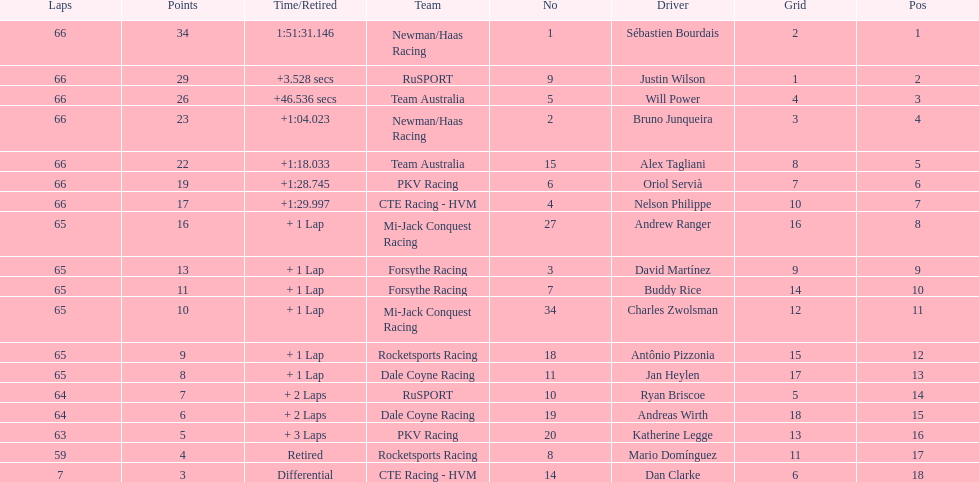At the 2006 gran premio telmex, did oriol servia or katherine legge complete more laps? Oriol Servià. Could you parse the entire table? {'header': ['Laps', 'Points', 'Time/Retired', 'Team', 'No', 'Driver', 'Grid', 'Pos'], 'rows': [['66', '34', '1:51:31.146', 'Newman/Haas Racing', '1', 'Sébastien Bourdais', '2', '1'], ['66', '29', '+3.528 secs', 'RuSPORT', '9', 'Justin Wilson', '1', '2'], ['66', '26', '+46.536 secs', 'Team Australia', '5', 'Will Power', '4', '3'], ['66', '23', '+1:04.023', 'Newman/Haas Racing', '2', 'Bruno Junqueira', '3', '4'], ['66', '22', '+1:18.033', 'Team Australia', '15', 'Alex Tagliani', '8', '5'], ['66', '19', '+1:28.745', 'PKV Racing', '6', 'Oriol Servià', '7', '6'], ['66', '17', '+1:29.997', 'CTE Racing - HVM', '4', 'Nelson Philippe', '10', '7'], ['65', '16', '+ 1 Lap', 'Mi-Jack Conquest Racing', '27', 'Andrew Ranger', '16', '8'], ['65', '13', '+ 1 Lap', 'Forsythe Racing', '3', 'David Martínez', '9', '9'], ['65', '11', '+ 1 Lap', 'Forsythe Racing', '7', 'Buddy Rice', '14', '10'], ['65', '10', '+ 1 Lap', 'Mi-Jack Conquest Racing', '34', 'Charles Zwolsman', '12', '11'], ['65', '9', '+ 1 Lap', 'Rocketsports Racing', '18', 'Antônio Pizzonia', '15', '12'], ['65', '8', '+ 1 Lap', 'Dale Coyne Racing', '11', 'Jan Heylen', '17', '13'], ['64', '7', '+ 2 Laps', 'RuSPORT', '10', 'Ryan Briscoe', '5', '14'], ['64', '6', '+ 2 Laps', 'Dale Coyne Racing', '19', 'Andreas Wirth', '18', '15'], ['63', '5', '+ 3 Laps', 'PKV Racing', '20', 'Katherine Legge', '13', '16'], ['59', '4', 'Retired', 'Rocketsports Racing', '8', 'Mario Domínguez', '11', '17'], ['7', '3', 'Differential', 'CTE Racing - HVM', '14', 'Dan Clarke', '6', '18']]} 